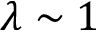<formula> <loc_0><loc_0><loc_500><loc_500>\lambda \sim 1</formula> 